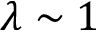<formula> <loc_0><loc_0><loc_500><loc_500>\lambda \sim 1</formula> 